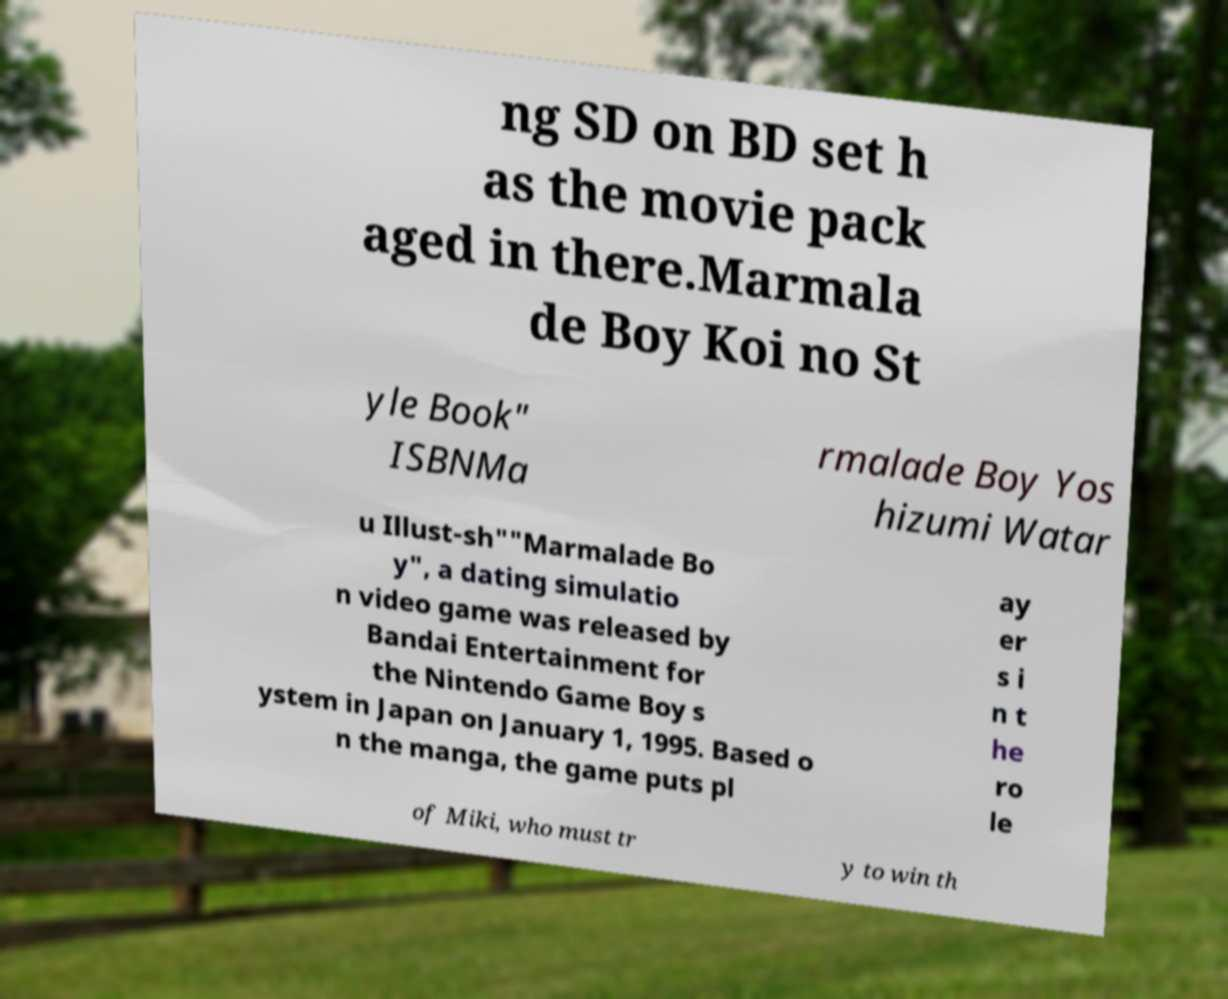Can you accurately transcribe the text from the provided image for me? ng SD on BD set h as the movie pack aged in there.Marmala de Boy Koi no St yle Book" ISBNMa rmalade Boy Yos hizumi Watar u Illust-sh""Marmalade Bo y", a dating simulatio n video game was released by Bandai Entertainment for the Nintendo Game Boy s ystem in Japan on January 1, 1995. Based o n the manga, the game puts pl ay er s i n t he ro le of Miki, who must tr y to win th 